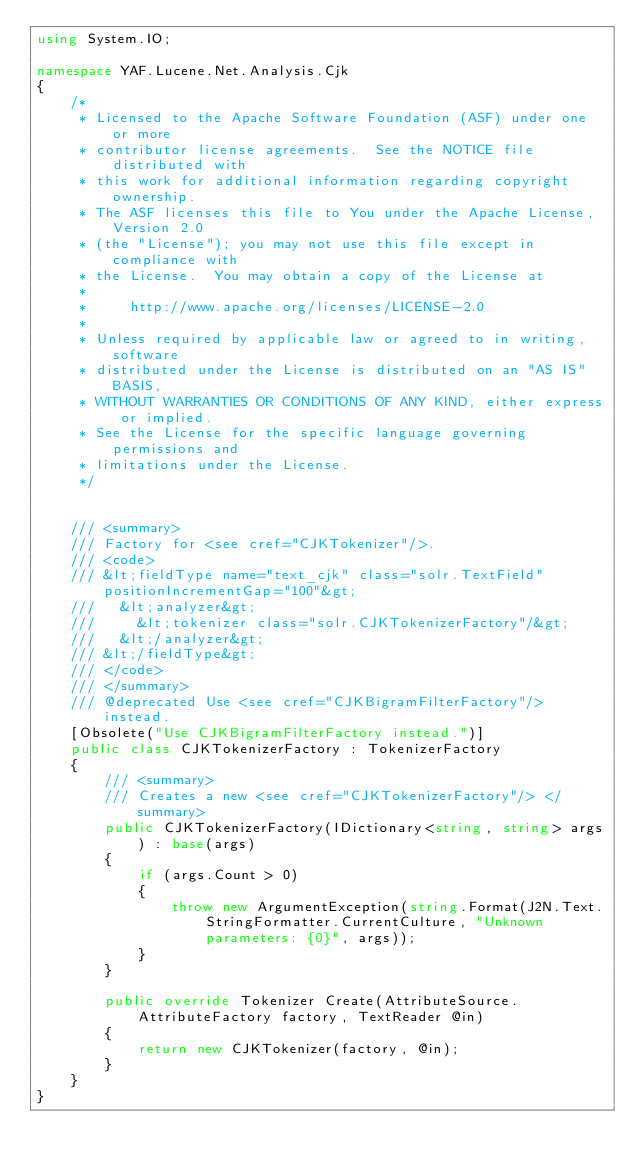Convert code to text. <code><loc_0><loc_0><loc_500><loc_500><_C#_>using System.IO;

namespace YAF.Lucene.Net.Analysis.Cjk
{
    /*
     * Licensed to the Apache Software Foundation (ASF) under one or more
     * contributor license agreements.  See the NOTICE file distributed with
     * this work for additional information regarding copyright ownership.
     * The ASF licenses this file to You under the Apache License, Version 2.0
     * (the "License"); you may not use this file except in compliance with
     * the License.  You may obtain a copy of the License at
     *
     *     http://www.apache.org/licenses/LICENSE-2.0
     *
     * Unless required by applicable law or agreed to in writing, software
     * distributed under the License is distributed on an "AS IS" BASIS,
     * WITHOUT WARRANTIES OR CONDITIONS OF ANY KIND, either express or implied.
     * See the License for the specific language governing permissions and
     * limitations under the License.
     */


    /// <summary>
    /// Factory for <see cref="CJKTokenizer"/>. 
    /// <code>
    /// &lt;fieldType name="text_cjk" class="solr.TextField" positionIncrementGap="100"&gt;
    ///   &lt;analyzer&gt;
    ///     &lt;tokenizer class="solr.CJKTokenizerFactory"/&gt;
    ///   &lt;/analyzer&gt;
    /// &lt;/fieldType&gt;
    /// </code>
    /// </summary>
    /// @deprecated Use <see cref="CJKBigramFilterFactory"/> instead. 
    [Obsolete("Use CJKBigramFilterFactory instead.")]
    public class CJKTokenizerFactory : TokenizerFactory
    {
        /// <summary>
        /// Creates a new <see cref="CJKTokenizerFactory"/> </summary>
        public CJKTokenizerFactory(IDictionary<string, string> args) : base(args)
        {
            if (args.Count > 0)
            {
                throw new ArgumentException(string.Format(J2N.Text.StringFormatter.CurrentCulture, "Unknown parameters: {0}", args));
            }
        }

        public override Tokenizer Create(AttributeSource.AttributeFactory factory, TextReader @in)
        {
            return new CJKTokenizer(factory, @in);
        }
    }
}</code> 